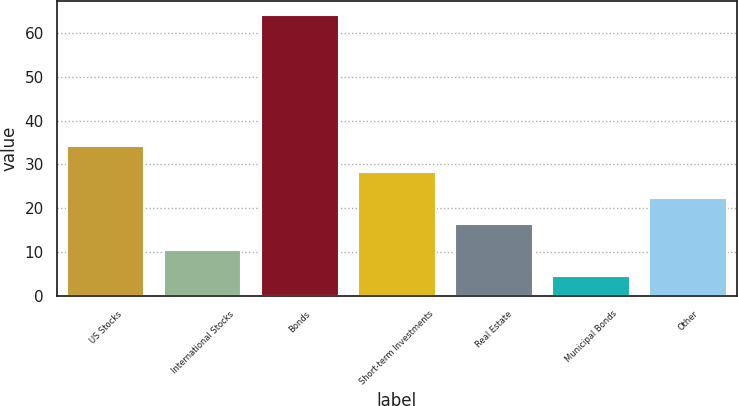<chart> <loc_0><loc_0><loc_500><loc_500><bar_chart><fcel>US Stocks<fcel>International Stocks<fcel>Bonds<fcel>Short-term Investments<fcel>Real Estate<fcel>Municipal Bonds<fcel>Other<nl><fcel>34.28<fcel>10.48<fcel>64<fcel>28.33<fcel>16.43<fcel>4.53<fcel>22.38<nl></chart> 